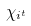Convert formula to latex. <formula><loc_0><loc_0><loc_500><loc_500>\chi _ { i ^ { t } }</formula> 